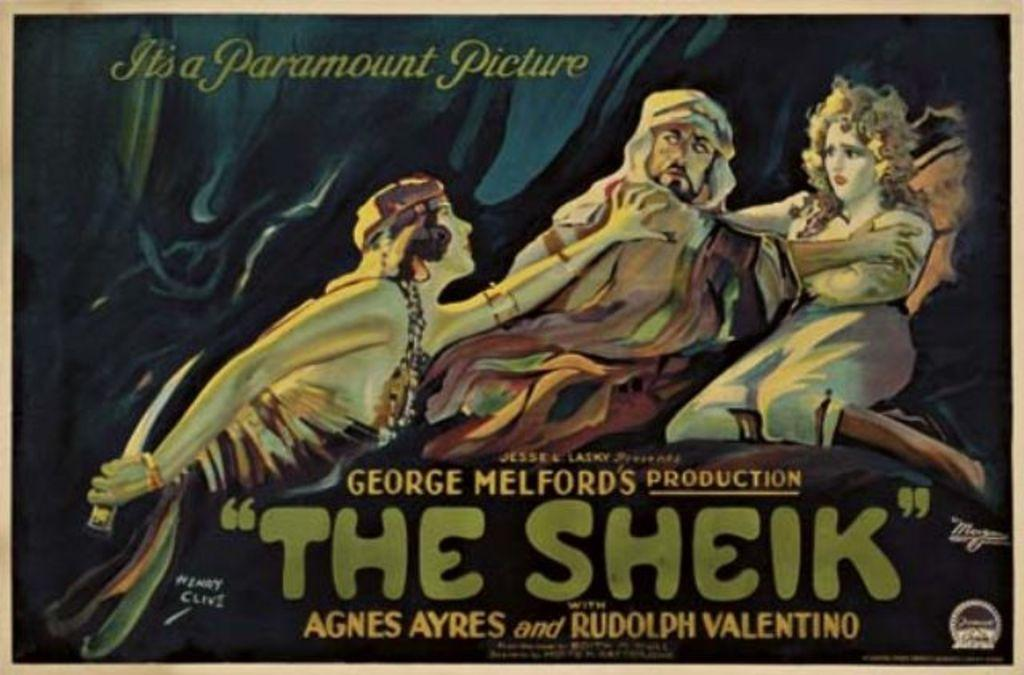<image>
Offer a succinct explanation of the picture presented. Poster for "The Shiek" which shows a man and two women. 